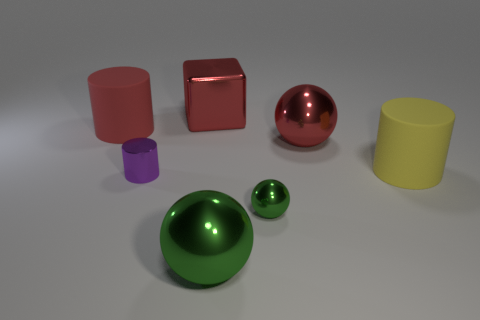The large rubber thing that is the same color as the cube is what shape?
Ensure brevity in your answer.  Cylinder. Is there a thing behind the matte object that is in front of the metal ball behind the tiny metallic ball?
Make the answer very short. Yes. Do the shiny block and the purple thing have the same size?
Your answer should be very brief. No. Are there the same number of big red cubes that are behind the large red metallic sphere and large red balls that are on the right side of the red cylinder?
Offer a terse response. Yes. There is a large matte object behind the big yellow cylinder; what shape is it?
Provide a succinct answer. Cylinder. What shape is the red metallic thing that is the same size as the red cube?
Offer a very short reply. Sphere. What color is the large cylinder behind the large sphere that is to the right of the big shiny thing that is in front of the large red shiny sphere?
Your answer should be compact. Red. Do the tiny purple thing and the red matte thing have the same shape?
Make the answer very short. Yes. Are there an equal number of yellow rubber cylinders that are behind the red sphere and large metal spheres?
Make the answer very short. No. How many other things are there of the same material as the big green sphere?
Make the answer very short. 4. 